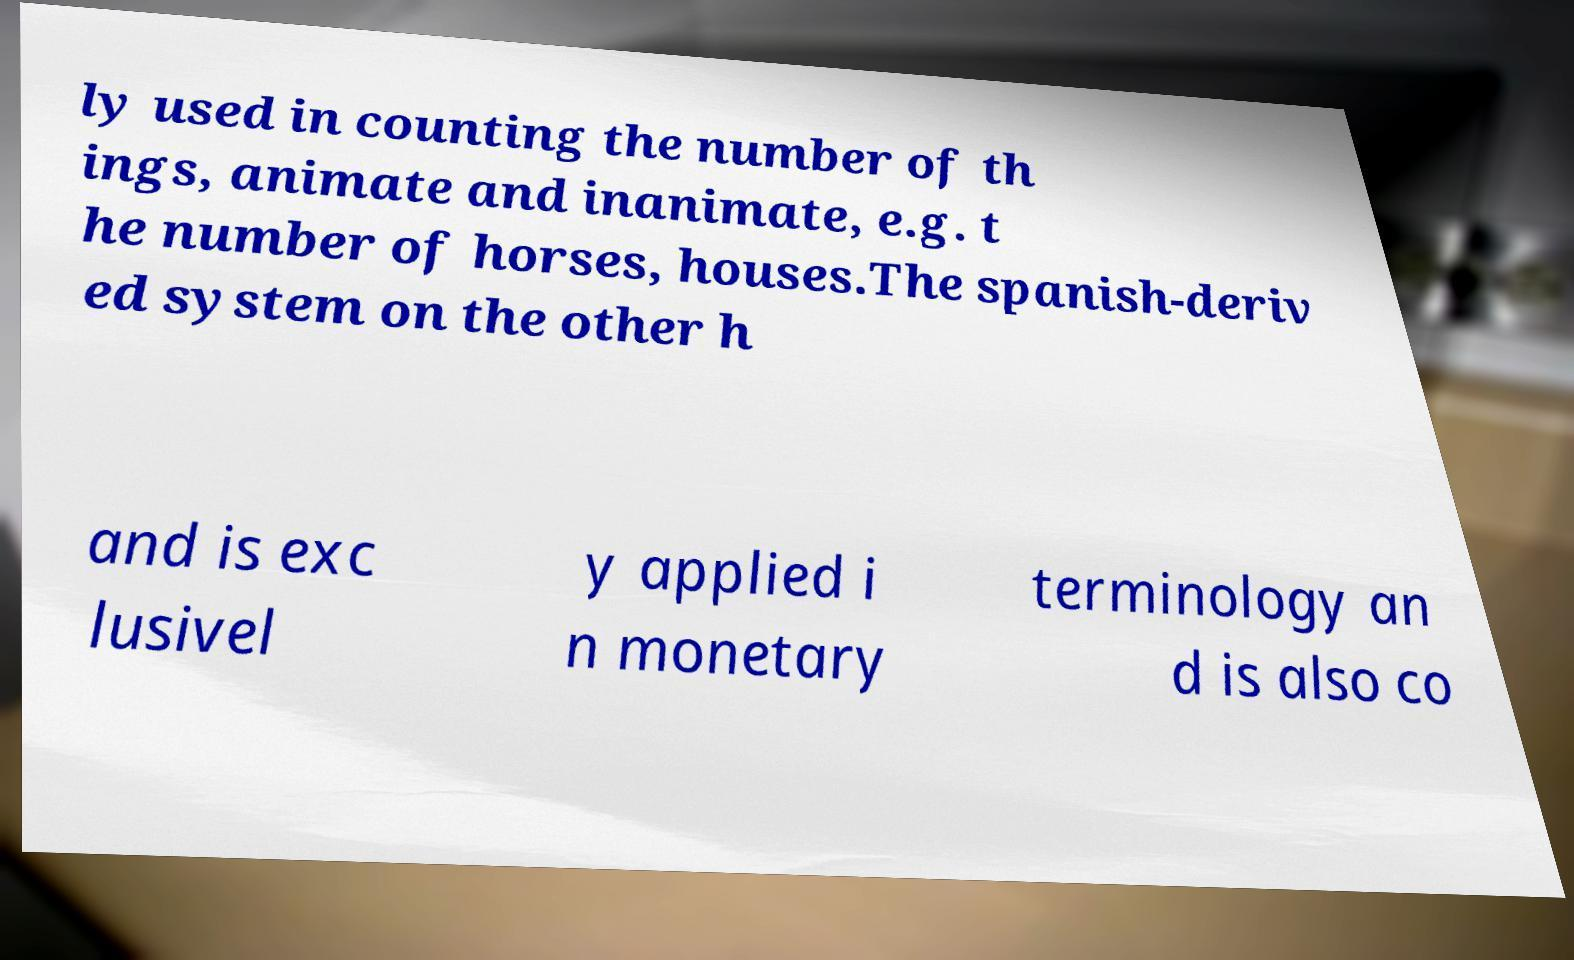What messages or text are displayed in this image? I need them in a readable, typed format. ly used in counting the number of th ings, animate and inanimate, e.g. t he number of horses, houses.The spanish-deriv ed system on the other h and is exc lusivel y applied i n monetary terminology an d is also co 